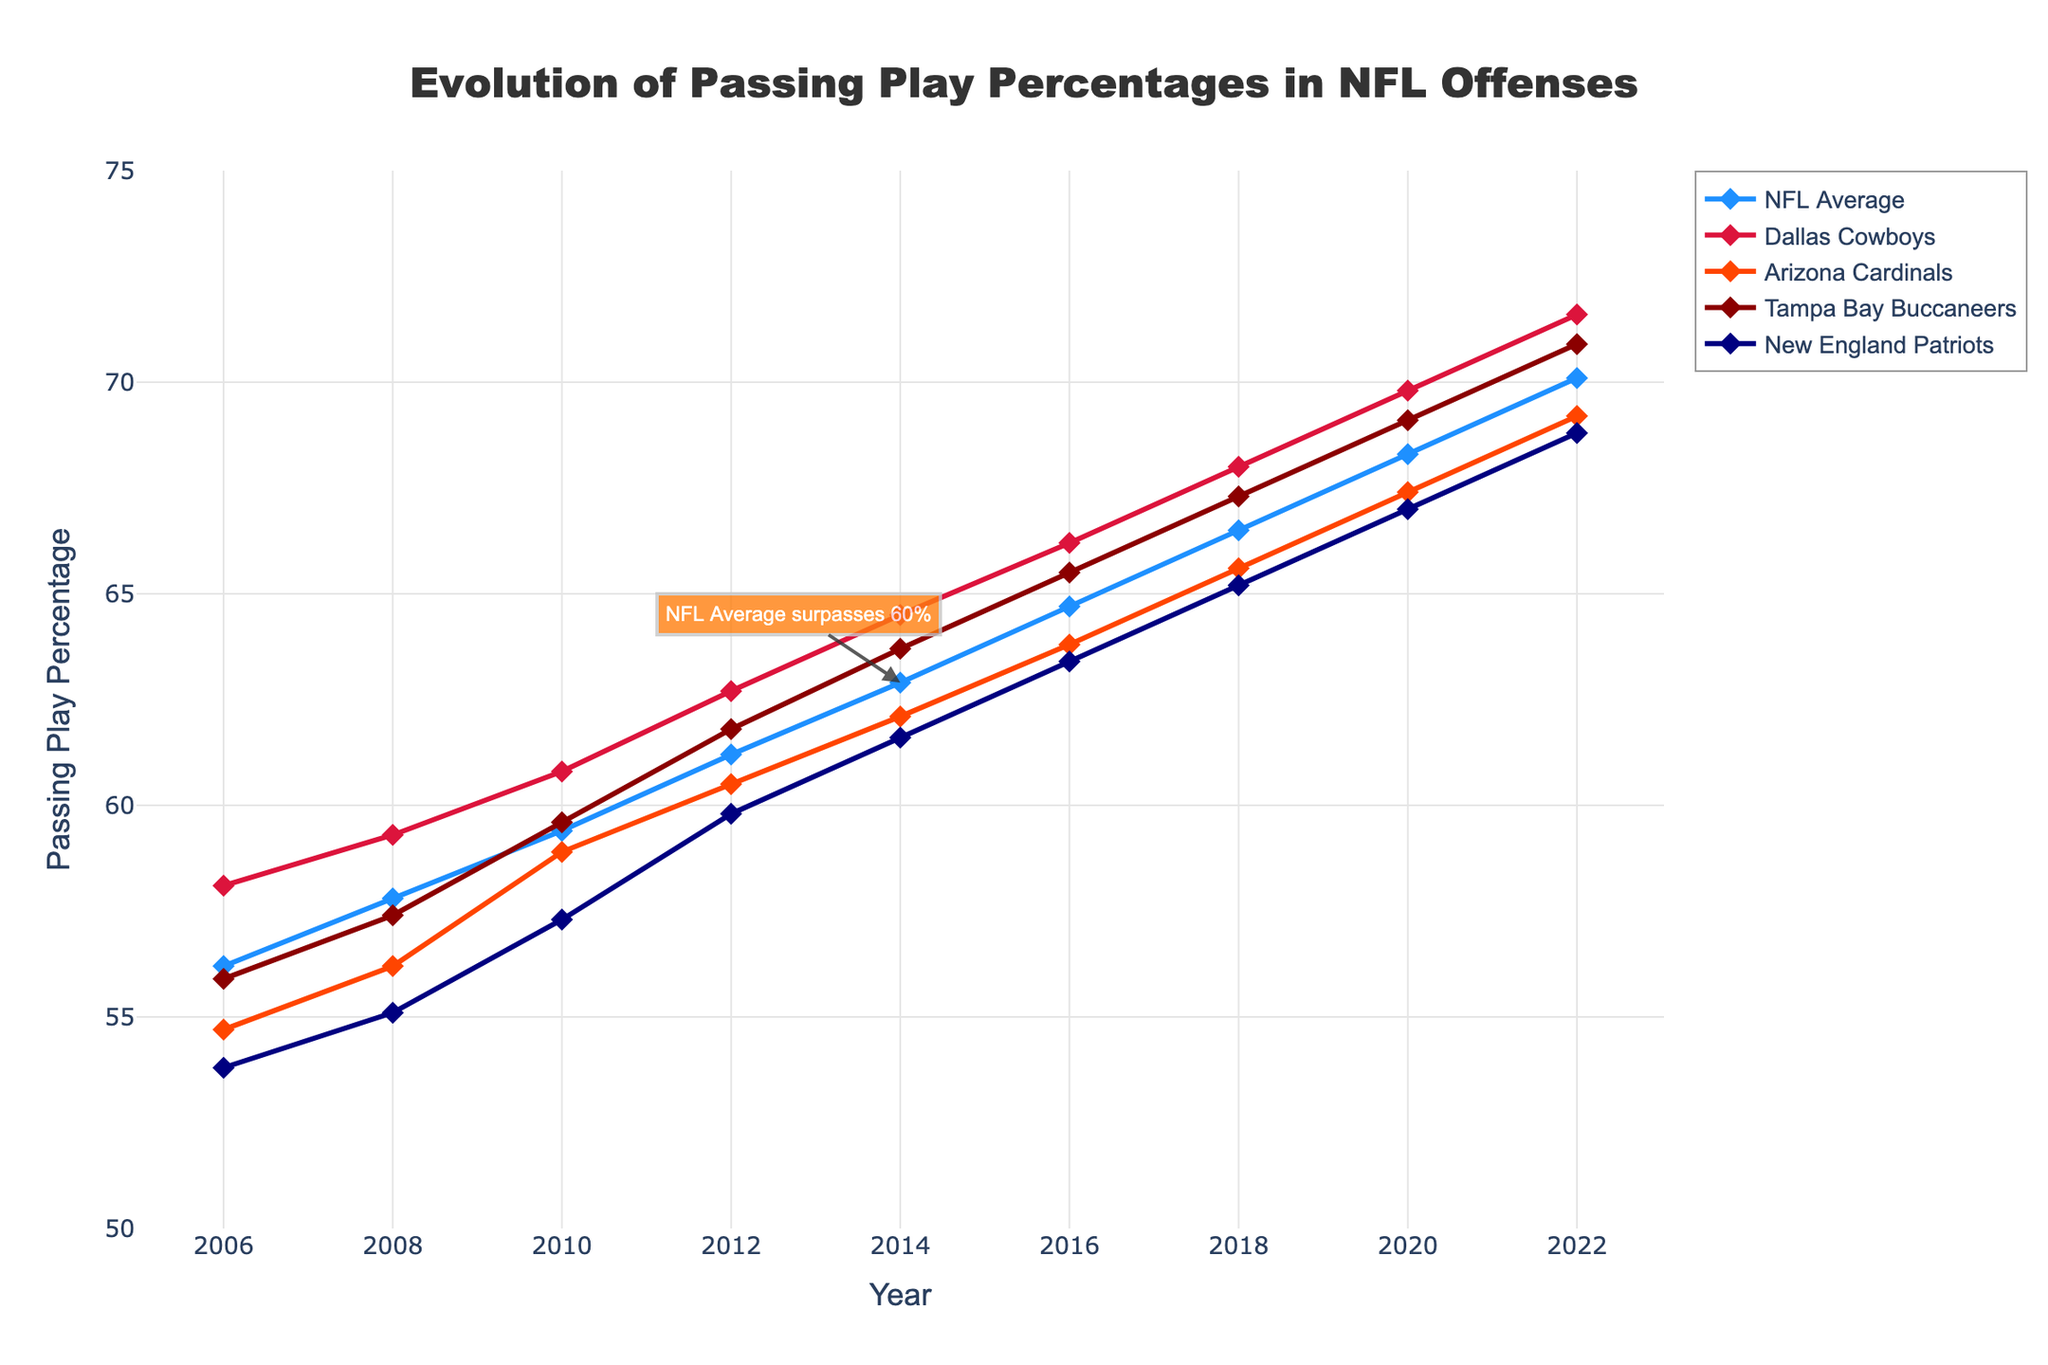What is the trend of the NFL Average passing play percentage from 2006 to 2022? Over the years from 2006 to 2022, the NFL Average passing play percentage shows a consistent increasing trend. It starts at 56.2% in 2006 and rises to 70.1% by 2022.
Answer: Increasing Which team had the highest passing play percentage in 2018? In 2018, by observing the topmost line among the five teams, the Dallas Cowboys had the highest passing play percentage at 68.0%.
Answer: Dallas Cowboys What is the difference in the passing play percentage of the Arizona Cardinals between 2006 and 2022? The passing play percentage of the Arizona Cardinals in 2006 was 54.7%, and in 2022 it was 69.2%. The difference is 69.2% - 54.7% = 14.5%.
Answer: 14.5% In which year did the NFL Average surpass 60% for the first time? By looking at the label "NFL Average surpasses 60%" and the corresponding year on the x-axis, it is evident that the NFL Average surpassed 60% in 2014.
Answer: 2014 Which team shows the most significant increase in passing play percentage from 2006 to 2022? To determine this, we calculate the increase for each team and compare them. The Dallas Cowboys increased from 58.1% in 2006 to 71.6% in 2022, a difference of 13.5%. The Arizona Cardinals increased from 54.7% to 69.2%, a difference of 14.5%. The Tampa Bay Buccaneers increased from 55.9% to 70.9%, a difference of 15.0%. The New England Patriots increased from 53.8% to 68.8%, a difference of 15.0%. Thus, the New England Patriots and the Tampa Bay Buccaneers both show the most significant increase of 15.0%.
Answer: New England Patriots and Tampa Bay Buccaneers What is the passing play percentage of the Dallas Cowboys in 2016? Observing the plotted line for the Dallas Cowboys in 2016, the passing play percentage is 66.2%.
Answer: 66.2% How does the trend of passing play percentage for the New England Patriots compare to the NFL Average from 2006 to 2022? The New England Patriots' passing play percentage follows a similar increasing trend as the NFL Average, starting at a lower percentage and consistently increasing over the years. Both lines show an upward trajectory, but the NFL Average always remains above or equal to the percentage for the New England Patriots.
Answer: Similar upward trend, NFL Average higher Compare the passing play percentages of the Tampa Bay Buccaneers and the Arizona Cardinals in 2020. In 2020, the passing play percentage for the Tampa Bay Buccaneers is 69.1%, while for the Arizona Cardinals, it is 67.4%. Thus, the Tampa Bay Buccaneers have a higher passing play percentage than the Arizona Cardinals in 2020.
Answer: Tampa Bay Buccaneers higher 